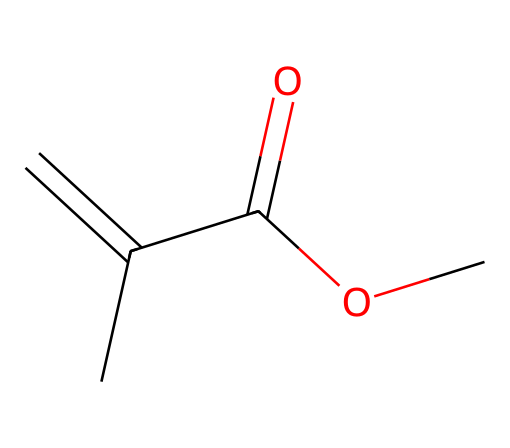What is the molecular formula of this compound? To find the molecular formula, we count the number of each type of atom present in the structure. From the SMILES notation, we identify: 4 carbon atoms, 6 hydrogen atoms, and 2 oxygen atoms, giving us the formula C4H6O2.
Answer: C4H6O2 How many double bonds are present in this structure? By analyzing the SMILES representation, we identify one double bond between the carbon atoms (C=C) and one double bond between carbon and oxygen (C=O). Therefore, there are a total of two double bonds.
Answer: 2 What functional groups are present in methyl methacrylate? The SMILES notation indicates the presence of an ester group (represented by -OC=O) and a carbon-carbon double bond (alkene). Thus, the functional groups are an ester and an alkene.
Answer: ester and alkene Which part of the molecule contributes to its toxicity? The toxicity in methyl methacrylate is often related to the reactive double bond (C=C) and the presence of the ester functional group, which can cause irritation and allergic reactions. Thus, the reactive parts of the molecule are the double bonds.
Answer: double bonds What state is methyl methacrylate usually found in at room temperature? Methyl methacrylate is a liquid at room temperature, which is typical for many small organic molecules that contain carbon, hydrogen, and oxygen. This characteristic can be determined from knowledge of similar compounds and its molecular structure.
Answer: liquid 